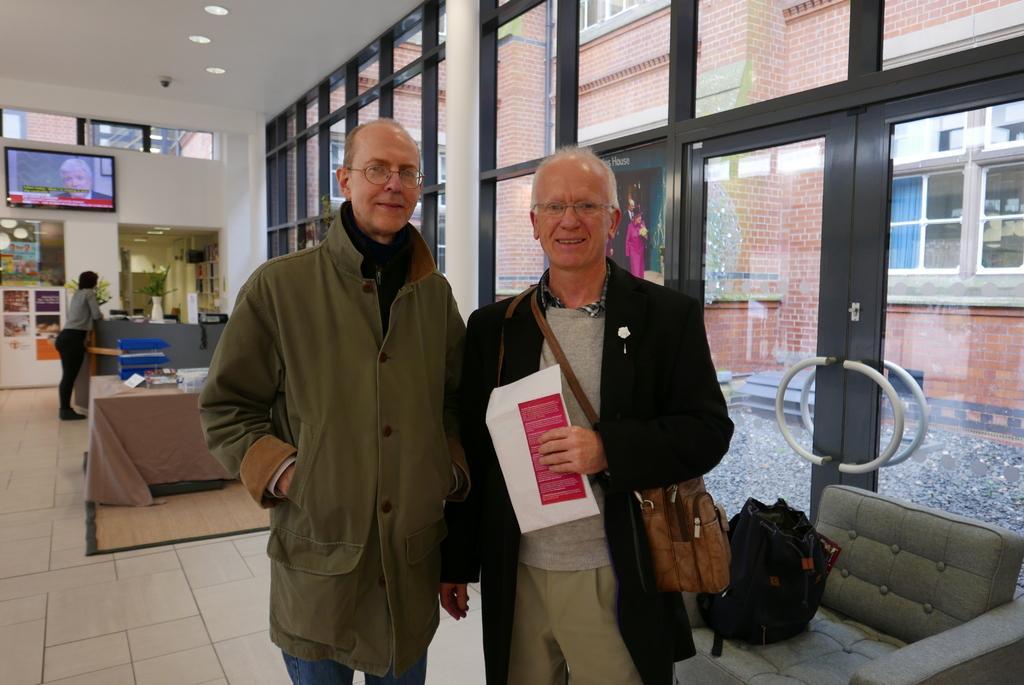How would you summarize this image in a sentence or two? In this image we can see three persons standing on the floor. One person is wearing coat and spectacles. Other person is carrying a bag. On to the right side of the image we can see a bag on the couch. on to the left side of the image we can see a television on the wall. In the background we can see doors ,building and a plant. 